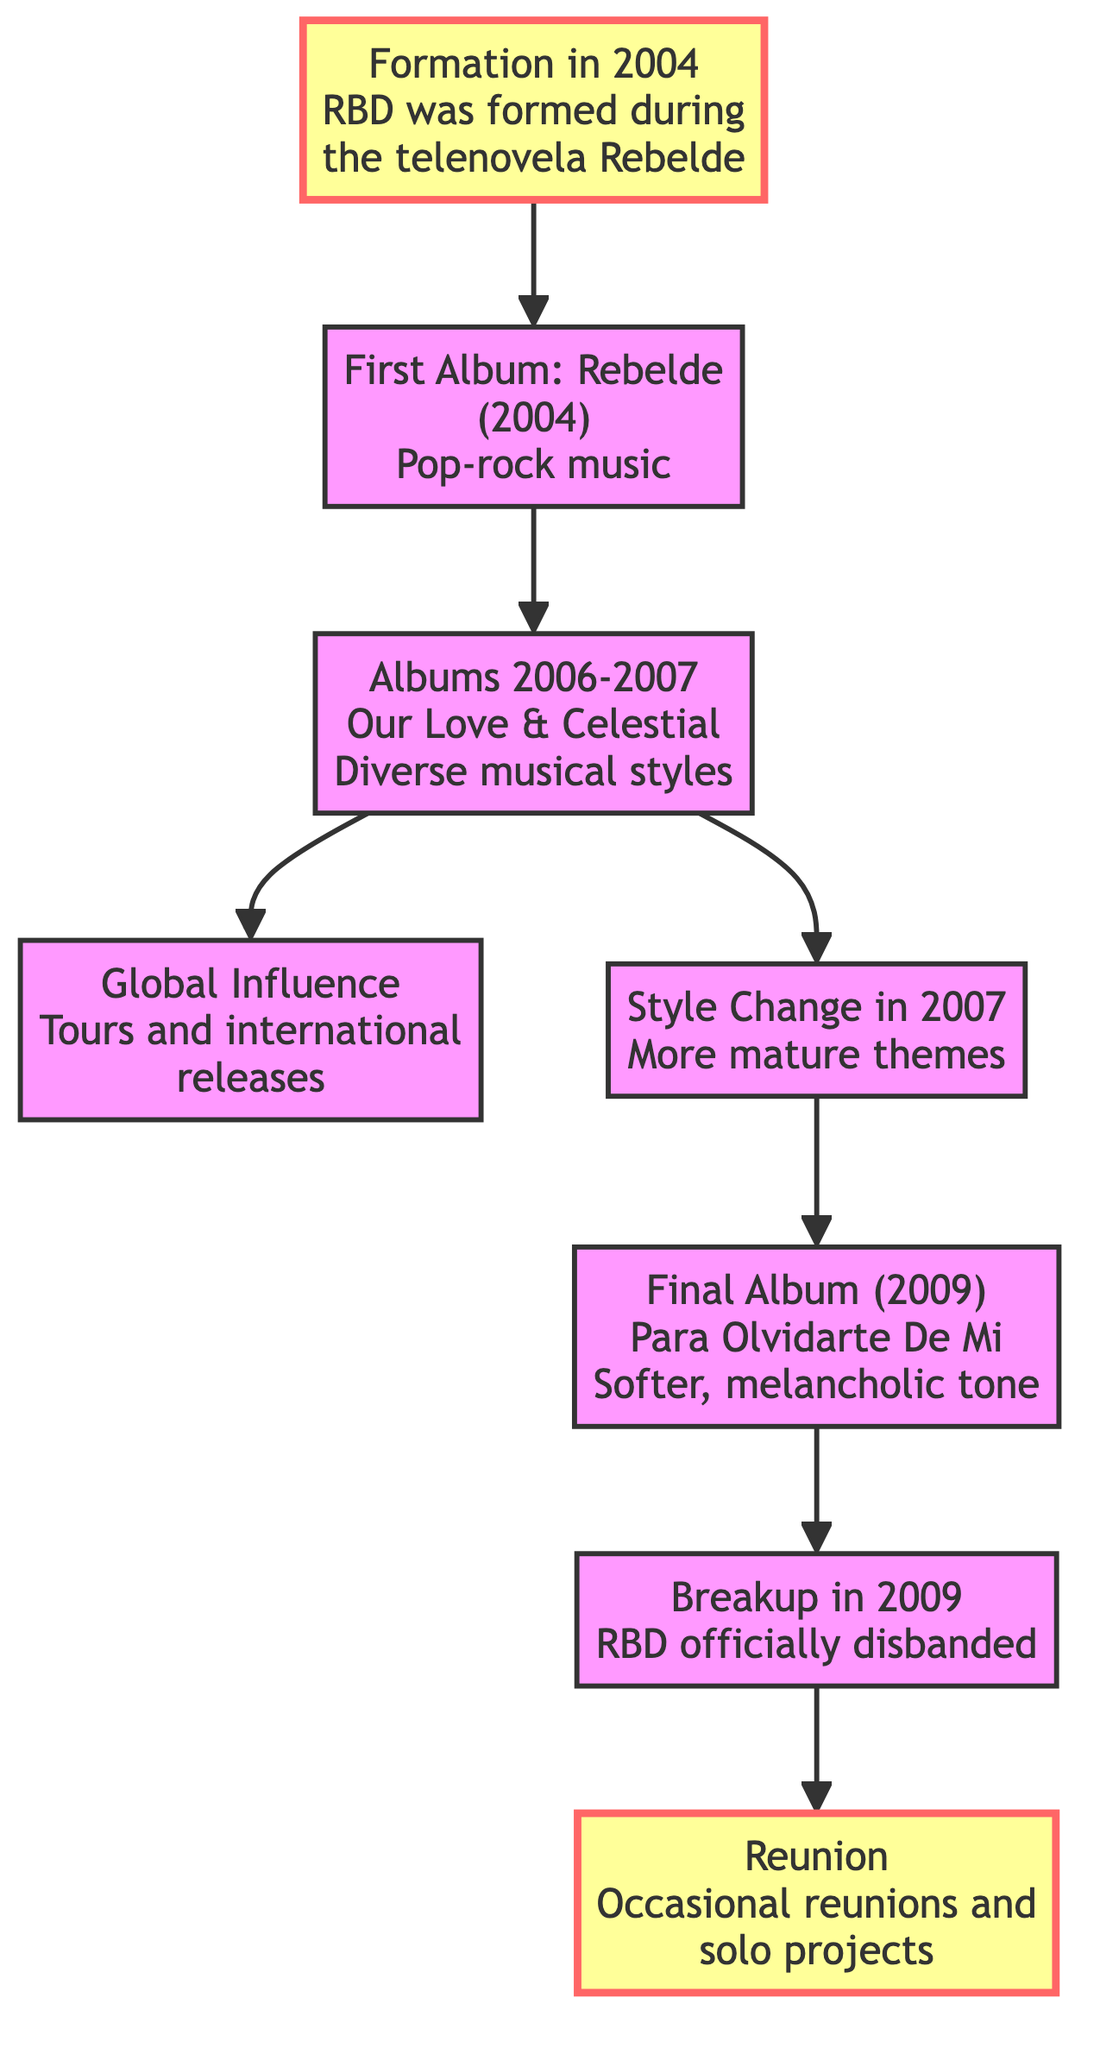What year was RBD formed? The diagram shows that RBD was formed in 2004, as indicated by the node labeled "Formation in 2004."
Answer: 2004 What is the title of RBD's first album? According to the diagram, the first album of RBD is "Rebelde," which is mentioned in the node "First Album: Rebelde."
Answer: Rebelde How many albums were released by RBD between 2006 and 2007? The node labeled "Albums 2006-2007" references two albums specifically, "Our Love" and "Celestial," which indicates there are two albums in this period.
Answer: 2 What musical style was primarily featured in RBD's first album? The diagram states that the first album's genre was pop-rock music, as indicated in the node for "First Album: Rebelde."
Answer: Pop-rock What significant change occurred in RBD's style in 2007? The node labeled "Style Change in 2007" describes the introduction of more mature themes in their music, which indicates the nature of the change.
Answer: More mature themes Which album marked a softer tone for RBD in 2009? The "Final Album" node specifies that the album "Para Olvidarte De Mi" released in 2009 marked a softer and melancholic tone for the band.
Answer: Para Olvidarte De Mi What event is indicated to have occurred in 2009? Based on the diagram, the event is the official disbanding of RBD, which is detailed in the "Breakup" node.
Answer: Breakup What has RBD engaged in after their breakup? The diagram mentions that RBD has participated in "occasional reunions and solo projects" which is illustrated in the "Reunion" node.
Answer: Occasional reunions and solo projects What led to RBD's global influence? The diagram shows a connection from "Albums 2006-2007" to "Global Influence," indicating that their tours and international releases contributed to their global presence.
Answer: Tours and international releases 